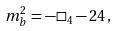<formula> <loc_0><loc_0><loc_500><loc_500>m ^ { 2 } _ { b } = - \square _ { 4 } - 2 4 \, ,</formula> 